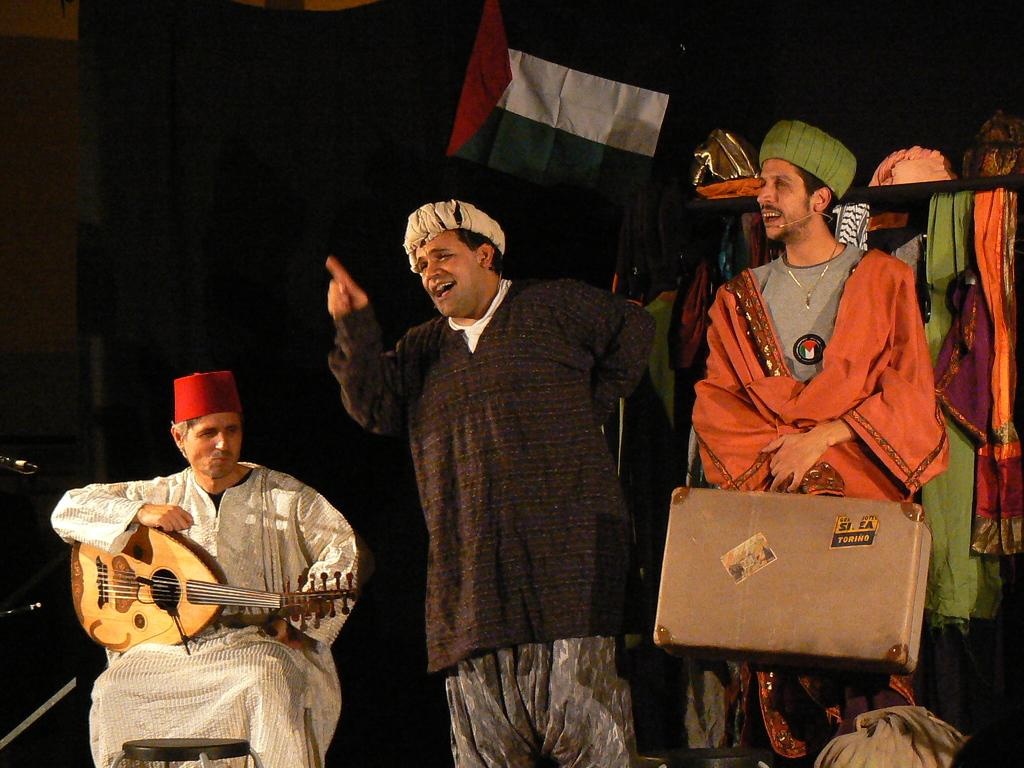How many people are present in the image? There are three people in the image. What are the people doing in the image? One person is holding a musical instrument, and another person is holding a bag. What can be seen in the background of the image? There are clothes visible in the background of the image. What type of engine can be seen in the image? There is no engine present in the image. How many people are the fifth person is contributing to the scene? There are only three people in the image, so there is no fifth person to contribute to the scene. 